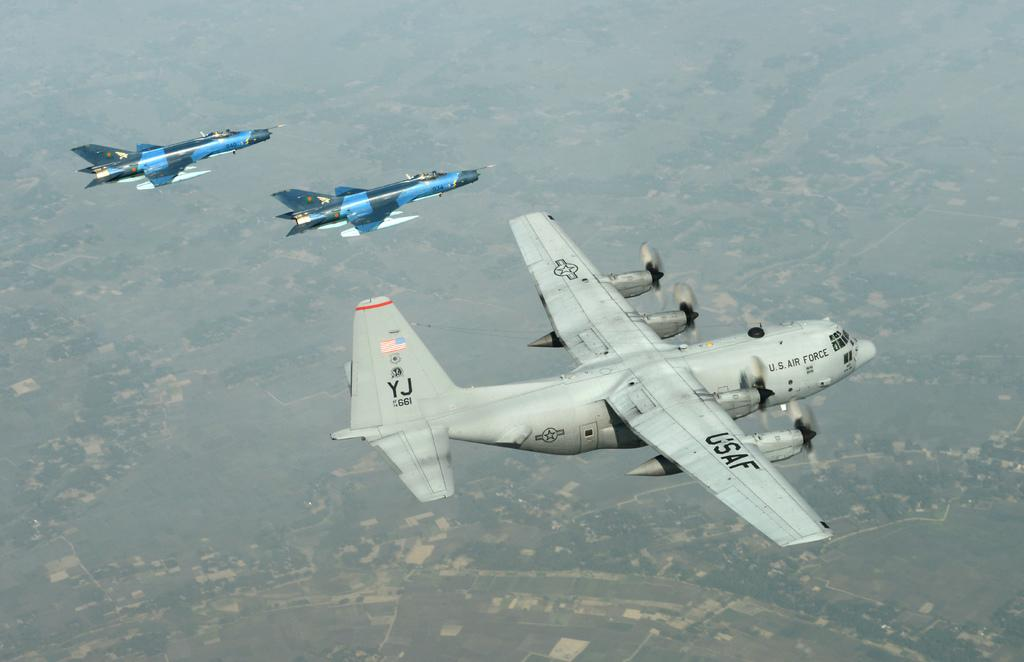<image>
Present a compact description of the photo's key features. A U.S. Air Force gray jet is flying next to two smaller blue jets. 